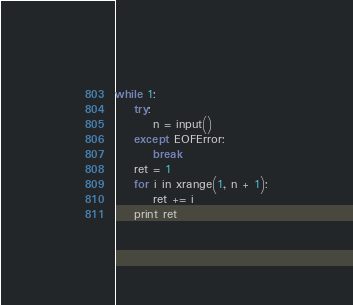Convert code to text. <code><loc_0><loc_0><loc_500><loc_500><_Python_>while 1:
    try:
        n = input()
    except EOFError:
        break
    ret = 1
    for i in xrange(1, n + 1):
        ret += i
    print ret</code> 